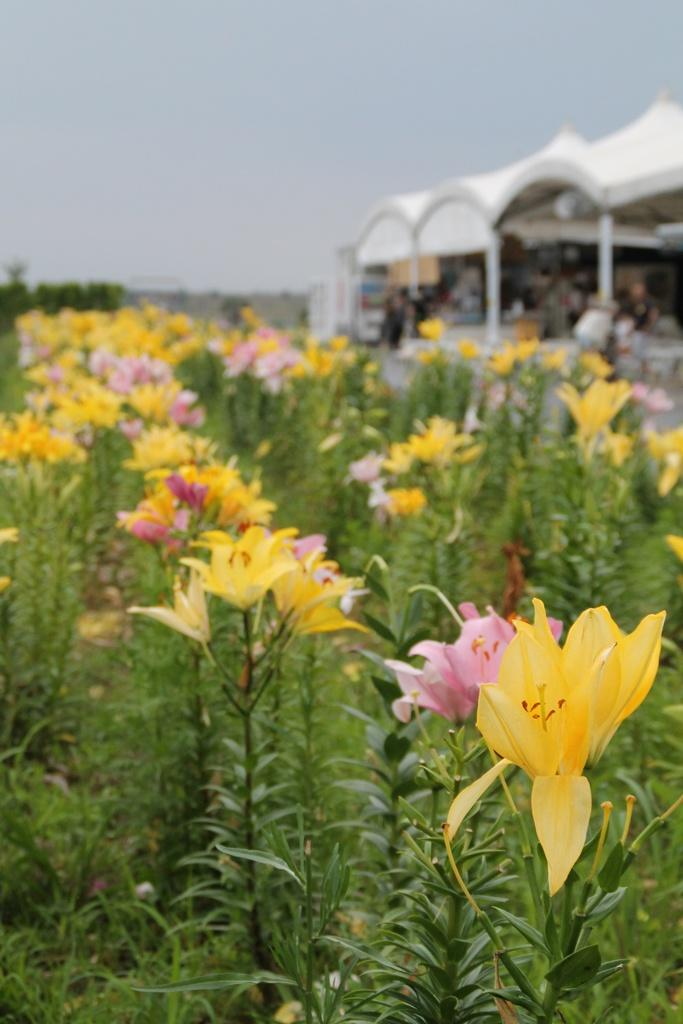What is the main subject of the image? The main subject of the image is plants with flowers. Can you describe the background of the image? The background of the image is blurred. How many fish can be seen swimming in the jail in the image? There are no fish or jails present in the image; it features plants with flowers and a blurred background. 